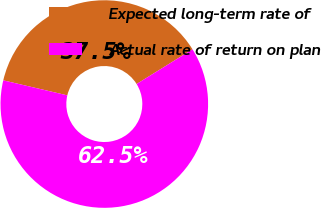<chart> <loc_0><loc_0><loc_500><loc_500><pie_chart><fcel>Expected long-term rate of<fcel>Actual rate of return on plan<nl><fcel>37.5%<fcel>62.5%<nl></chart> 